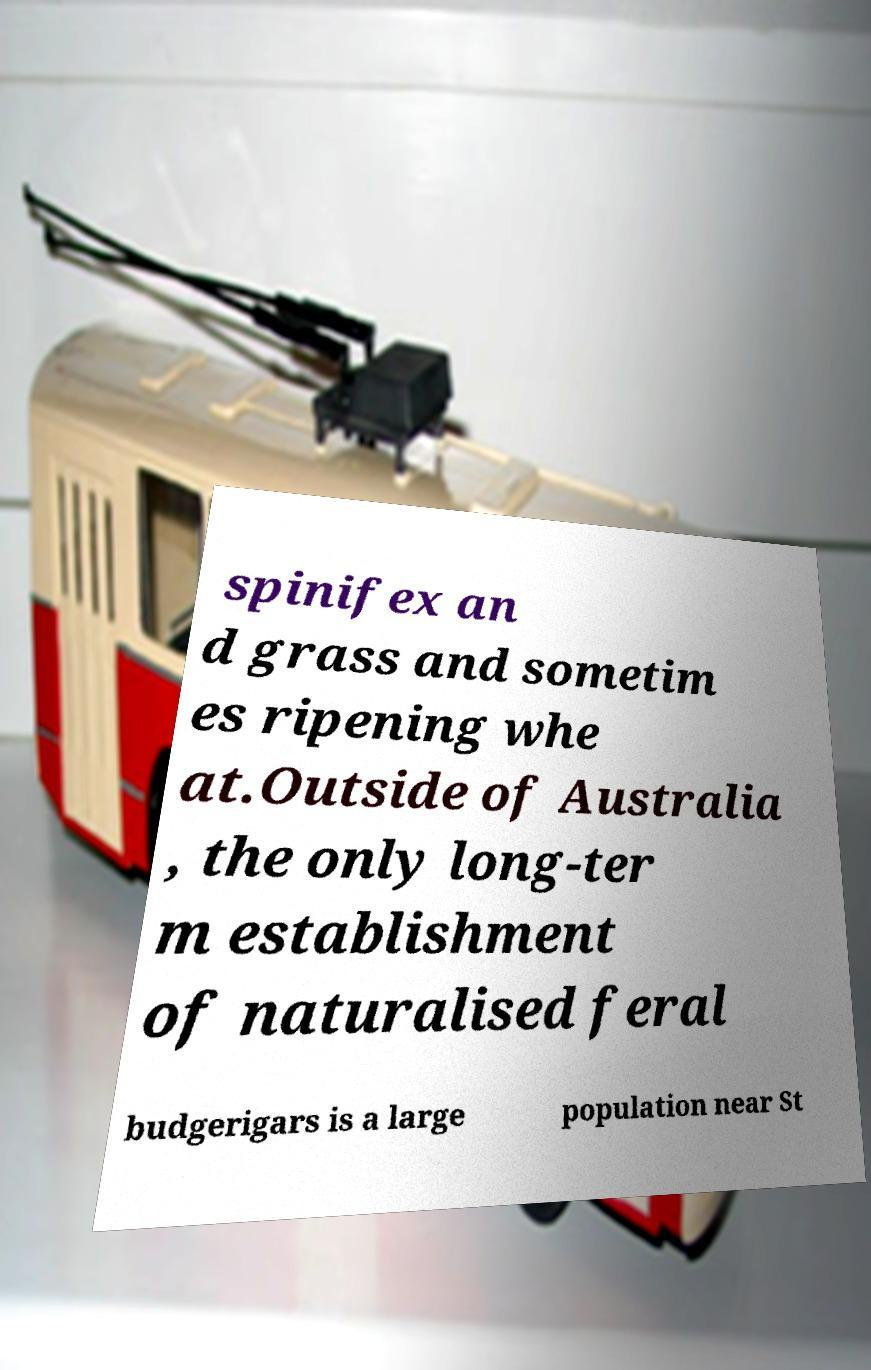Can you read and provide the text displayed in the image?This photo seems to have some interesting text. Can you extract and type it out for me? spinifex an d grass and sometim es ripening whe at.Outside of Australia , the only long-ter m establishment of naturalised feral budgerigars is a large population near St 